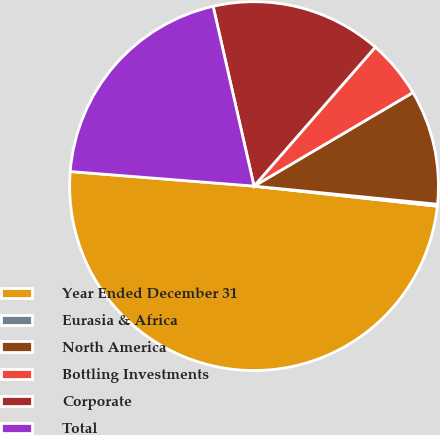<chart> <loc_0><loc_0><loc_500><loc_500><pie_chart><fcel>Year Ended December 31<fcel>Eurasia & Africa<fcel>North America<fcel>Bottling Investments<fcel>Corporate<fcel>Total<nl><fcel>49.52%<fcel>0.17%<fcel>10.04%<fcel>5.11%<fcel>14.98%<fcel>20.18%<nl></chart> 